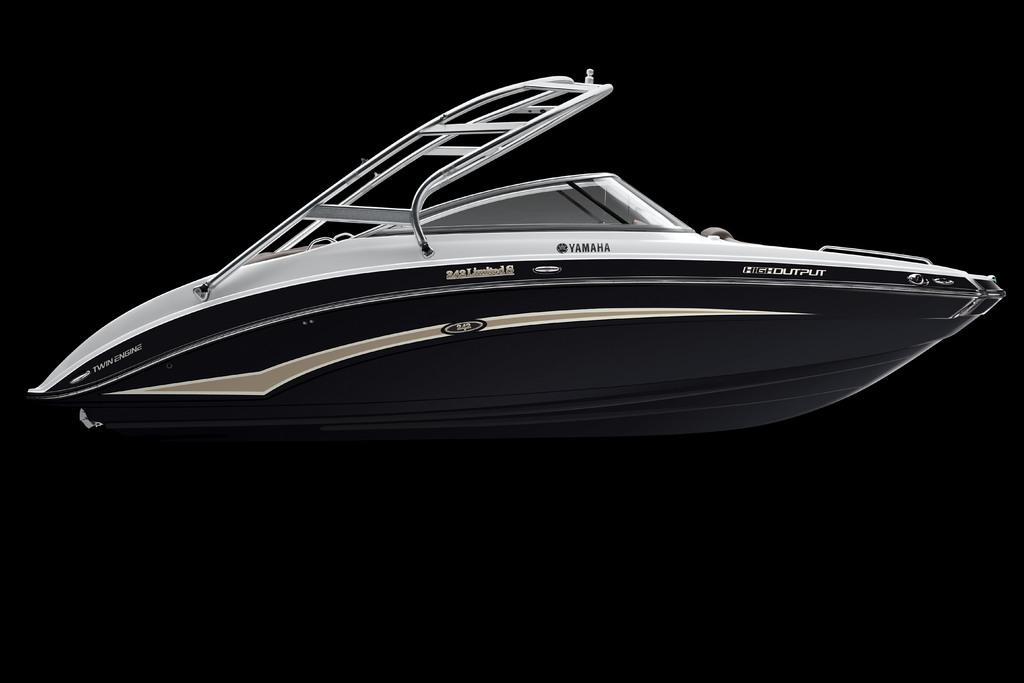<image>
Present a compact description of the photo's key features. A gray and silver Yamaha speed boat is shown on its side against the black background. 